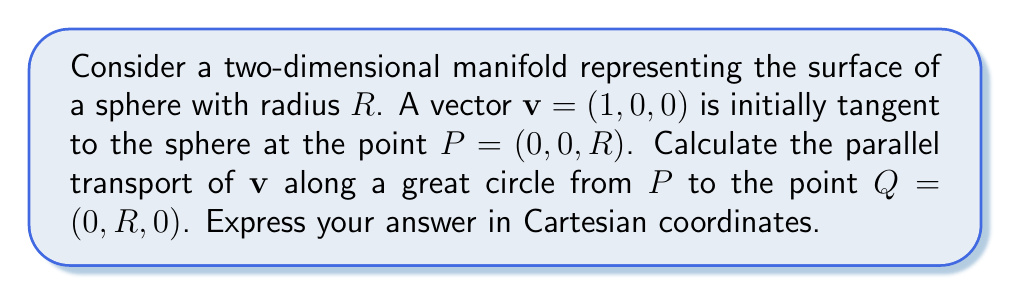Show me your answer to this math problem. To solve this problem, we'll follow these steps:

1) First, we need to understand that parallel transport preserves the angle between the vector and the curve it's being transported along. In this case, the vector will remain perpendicular to the great circle.

2) The great circle from $P$ to $Q$ is a 90-degree rotation about the x-axis. We can represent this rotation using a rotation matrix:

   $$R_x(\theta) = \begin{pmatrix}
   1 & 0 & 0 \\
   0 & \cos\theta & -\sin\theta \\
   0 & \sin\theta & \cos\theta
   \end{pmatrix}$$

   where $\theta = -\frac{\pi}{2}$ (negative because we're rotating clockwise).

3) However, we can't simply apply this rotation to our vector, as that would rotate it out of the tangent plane. Instead, we need to consider how the tangent plane itself rotates.

4) At the initial point $P$, the tangent plane is the xy-plane. At the final point $Q$, the tangent plane is the xz-plane.

5) Our initial vector $\mathbf{v} = (1, 0, 0)$ is already in the direction of the x-axis, which is the axis of rotation. Therefore, the parallel transport will keep this vector unchanged relative to the rotating tangent plane.

6) In the final tangent plane at $Q$, the vector will still point in the "horizontal" direction of this plane, which is now the positive x-direction.

Therefore, the parallel transported vector at $Q$ will be $\mathbf{v}_Q = (1, 0, 0)$, which is the same as the initial vector in Cartesian coordinates.

[asy]
import three;
size(200);
currentprojection=perspective(6,3,2);
draw(surface(sphere((0,0,0),1)),paleblue+opacity(.5));
draw(arc((0,0,0),(0,0,1),(0,1,0)),red);
draw((0,0,1)--(1,0,1),blue,Arrow3);
draw((0,1,0)--(1,1,0),blue,Arrow3);
label("P",(0,0,1),N);
label("Q",(0,1,0),E);
label("v",(1,0,1),NE);
label("v'",(1,1,0),NE);
[/asy]
Answer: $(1, 0, 0)$ 